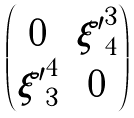Convert formula to latex. <formula><loc_0><loc_0><loc_500><loc_500>\begin{pmatrix} 0 & { \xi ^ { \prime } } ^ { 3 } _ { 4 } \\ { \xi ^ { \prime } } ^ { 4 } _ { 3 } & 0 \end{pmatrix}</formula> 